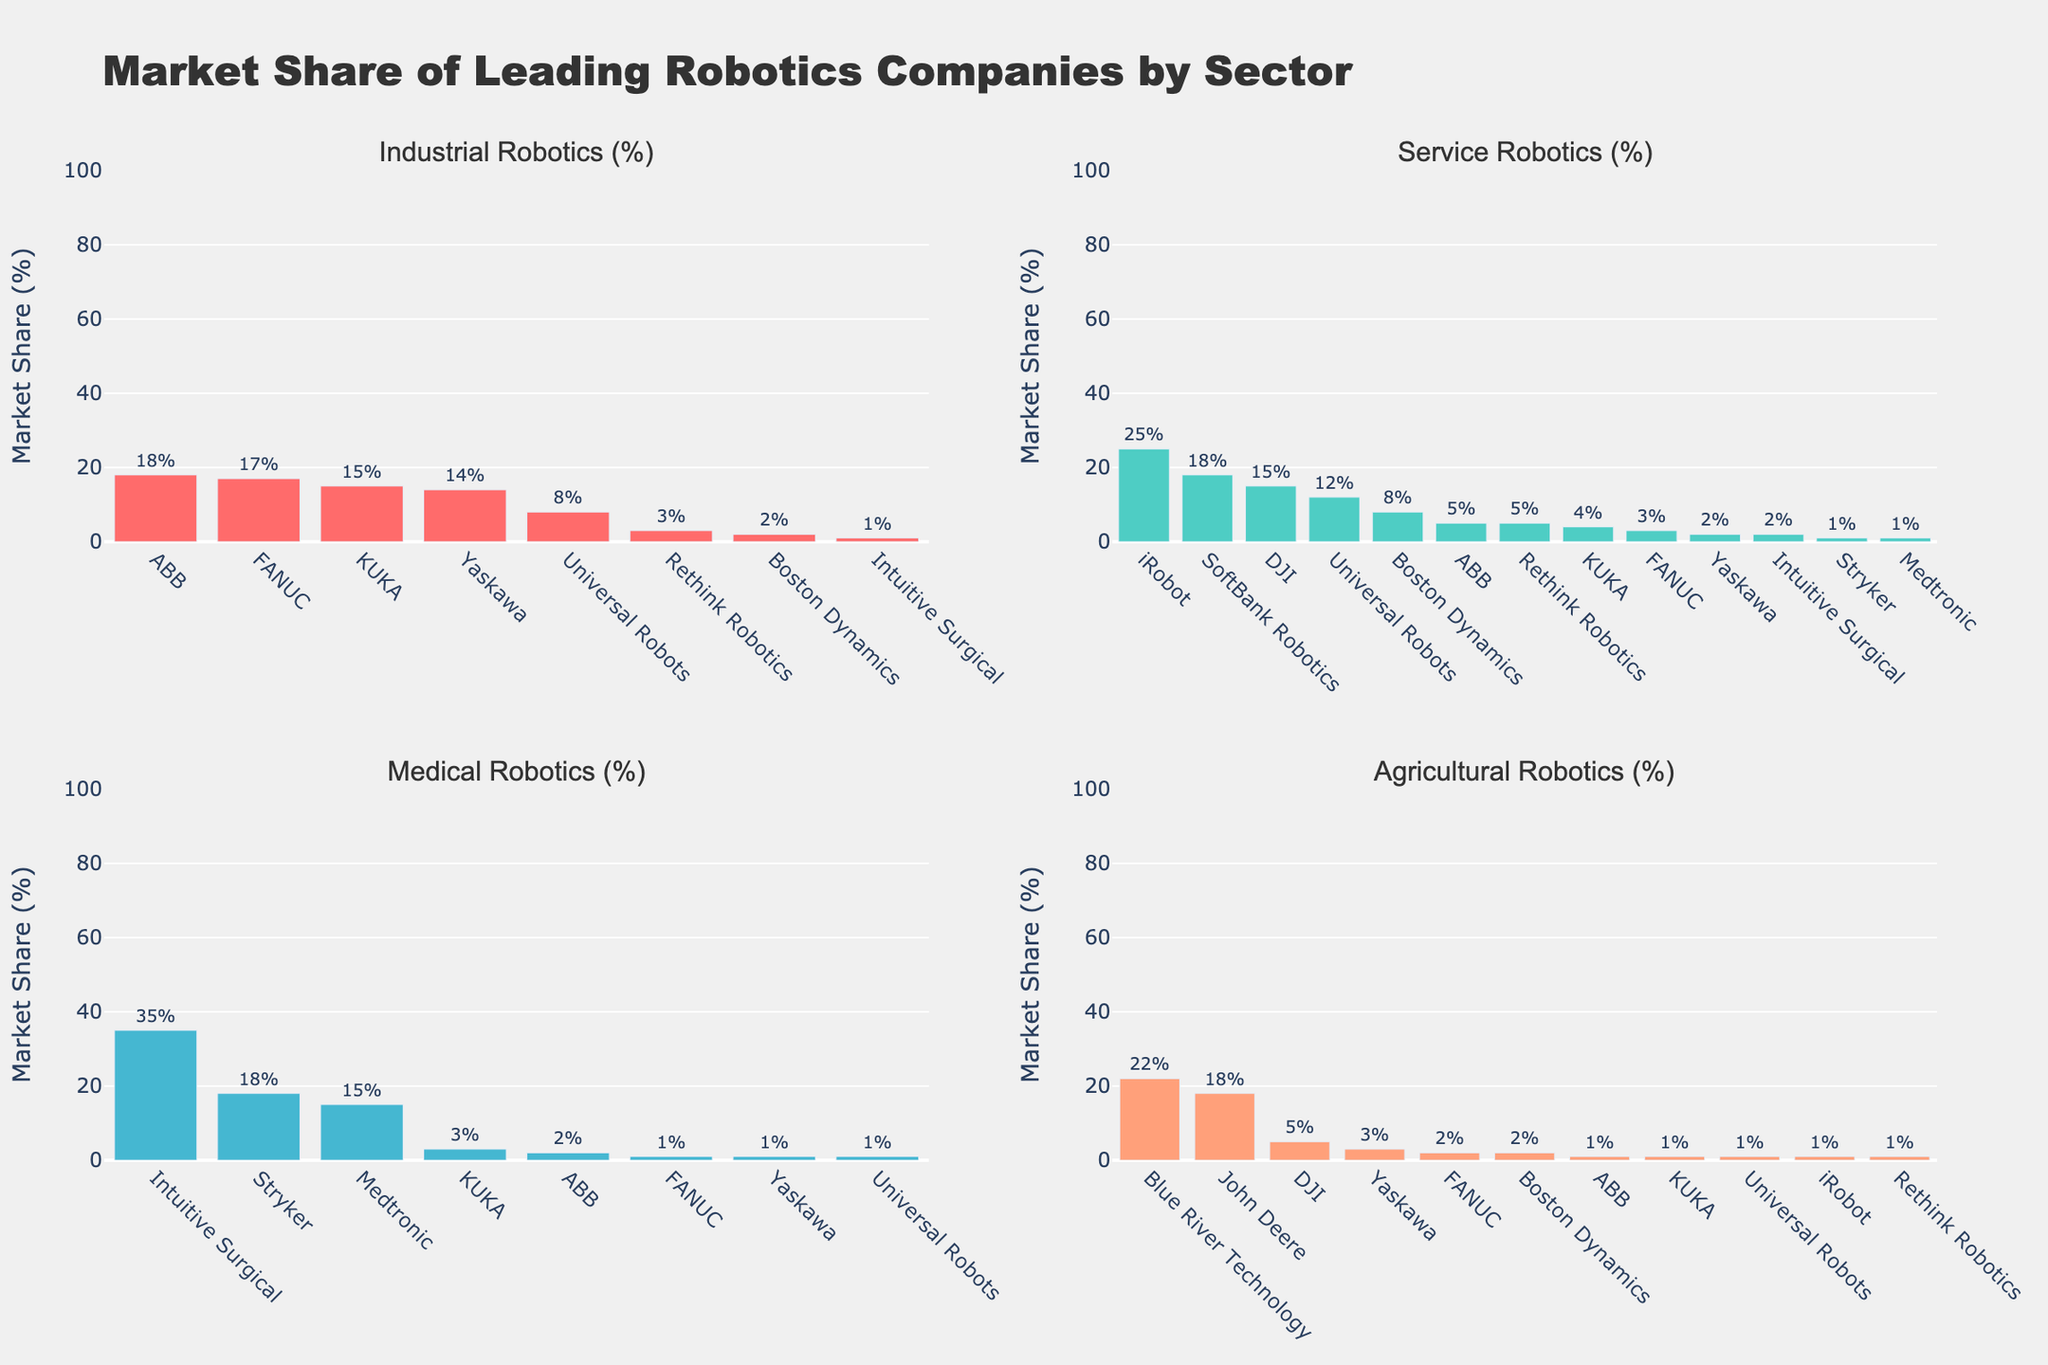Which company has the largest market share in the Industrial Robotics sector? The tallest bar in the subplot for Industrial Robotics represents ABB, with a market share of 18%.
Answer: ABB Which two companies have equal market share in Agricultural Robotics? Both Yaskawa and DJI have bars of equal height in the Agricultural Robotics subplot, indicating they each have a 3% market share.
Answer: Yaskawa and DJI How does the market share of Intuitive Surgical in Medical Robotics compare to the market share of Medtronic in the same sector? Intuitive Surgical has a taller bar than Medtronic in Medical Robotics, indicating a higher market share of 35% compared to Medtronic's 15%.
Answer: Intuitive Surgical has a higher market share What is the combined market share of the top two companies in the Service Robotics sector? The top two companies in Service Robotics are iRobot (25%) and SoftBank Robotics (18%) with their respective bars indicating these market shares. The combined market share is 25 + 18 = 43%.
Answer: 43% Which sector does Universal Robots have the highest market share in? The tallest bar for Universal Robots is in the Service Robotics subplot, indicating its highest market share of 12%.
Answer: Service Robotics How much greater is the market share of Blue River Technology in Agricultural Robotics compared to Boston Dynamics in the same sector? Blue River Technology has a market share of 22% in Agricultural Robotics, whereas Boston Dynamics has 2%; the difference is 22 - 2 = 20%.
Answer: 20% What is the range of market shares in the Medical Robotics sector? The lowest market share in Medical Robotics is from Universal Robots (1%) and the highest is from Intuitive Surgical (35%), thus the range is 35 - 1 = 34%.
Answer: 34% What is the difference in market share between the top company in Industrial Robotics and the top company in Service Robotics? ABB leads in Industrial Robotics with 18%, while iRobot leads in Service Robotics with 25%; the difference is 25 - 18 = 7%.
Answer: 7% Which company holds a market share in all sectors? The only company that has a bar in each subplot is Universal Robots, indicating it holds a market share in all sectors.
Answer: Universal Robots 